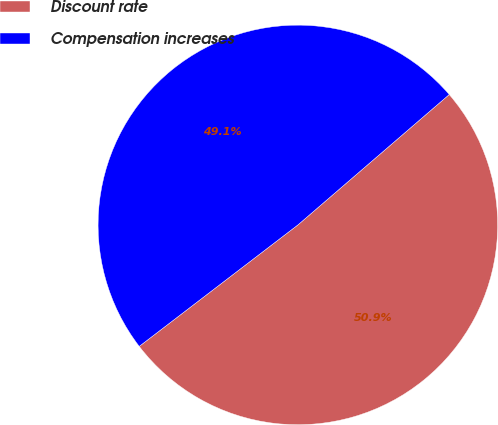Convert chart to OTSL. <chart><loc_0><loc_0><loc_500><loc_500><pie_chart><fcel>Discount rate<fcel>Compensation increases<nl><fcel>50.92%<fcel>49.08%<nl></chart> 